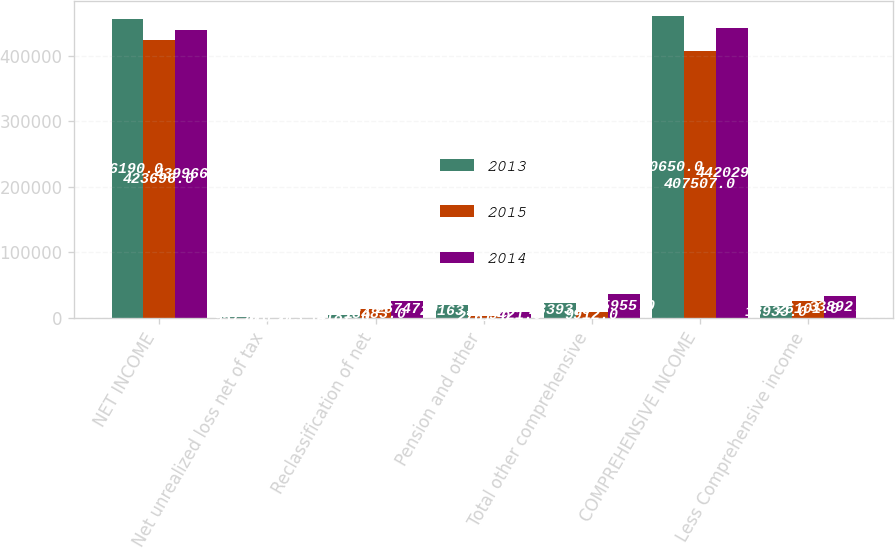<chart> <loc_0><loc_0><loc_500><loc_500><stacked_bar_chart><ecel><fcel>NET INCOME<fcel>Net unrealized loss net of tax<fcel>Reclassification of net<fcel>Pension and other<fcel>Total other comprehensive<fcel>COMPREHENSIVE INCOME<fcel>Less Comprehensive income<nl><fcel>2013<fcel>456190<fcel>957<fcel>4187<fcel>20163<fcel>23393<fcel>460650<fcel>18933<nl><fcel>2015<fcel>423696<fcel>810<fcel>13483<fcel>2761<fcel>9912<fcel>407507<fcel>26101<nl><fcel>2014<fcel>439966<fcel>213<fcel>26747<fcel>9421<fcel>35955<fcel>442029<fcel>33892<nl></chart> 